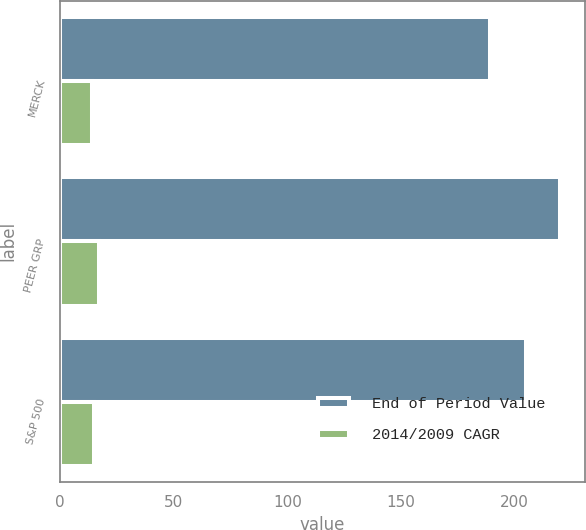<chart> <loc_0><loc_0><loc_500><loc_500><stacked_bar_chart><ecel><fcel>MERCK<fcel>PEER GRP<fcel>S&P 500<nl><fcel>End of Period Value<fcel>189<fcel>220<fcel>205<nl><fcel>2014/2009 CAGR<fcel>14<fcel>17<fcel>15<nl></chart> 